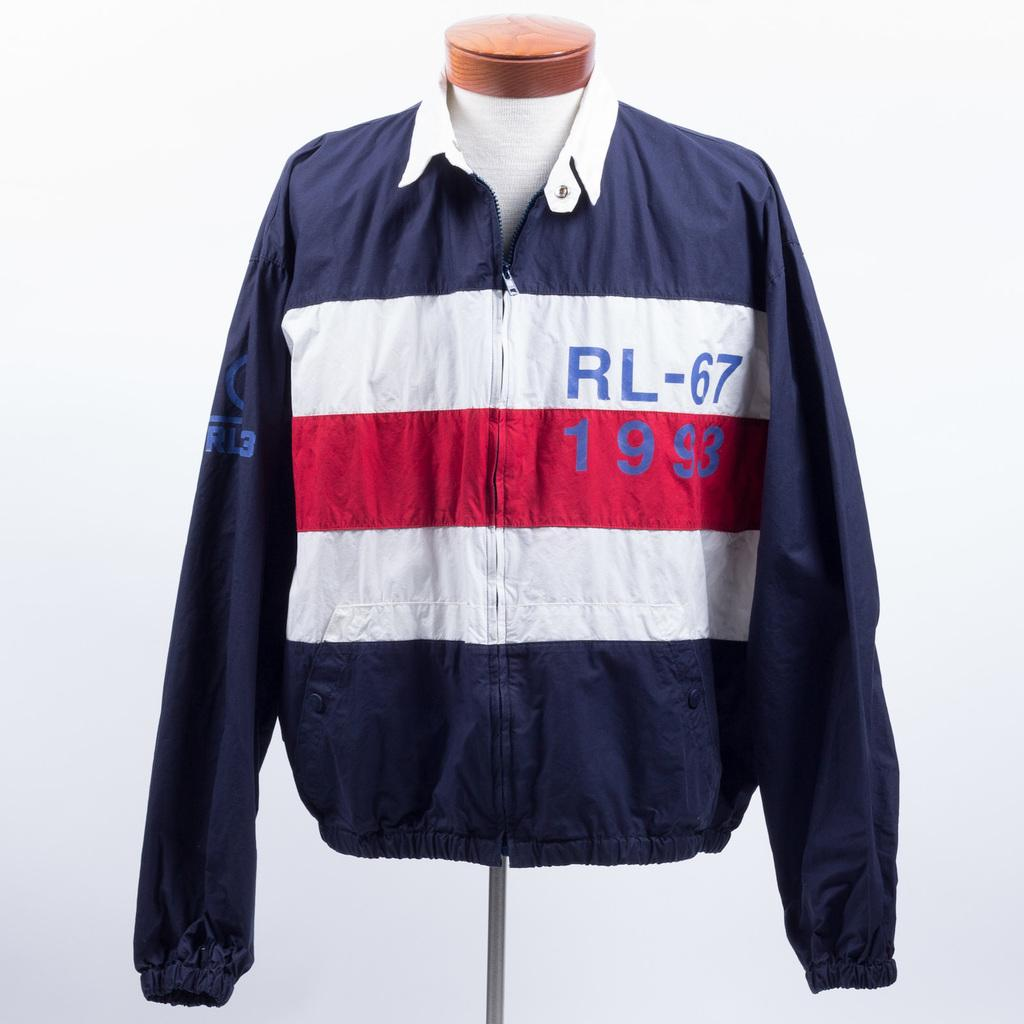<image>
Share a concise interpretation of the image provided. A beautiful blue, red and white sport jacket of 1993. 